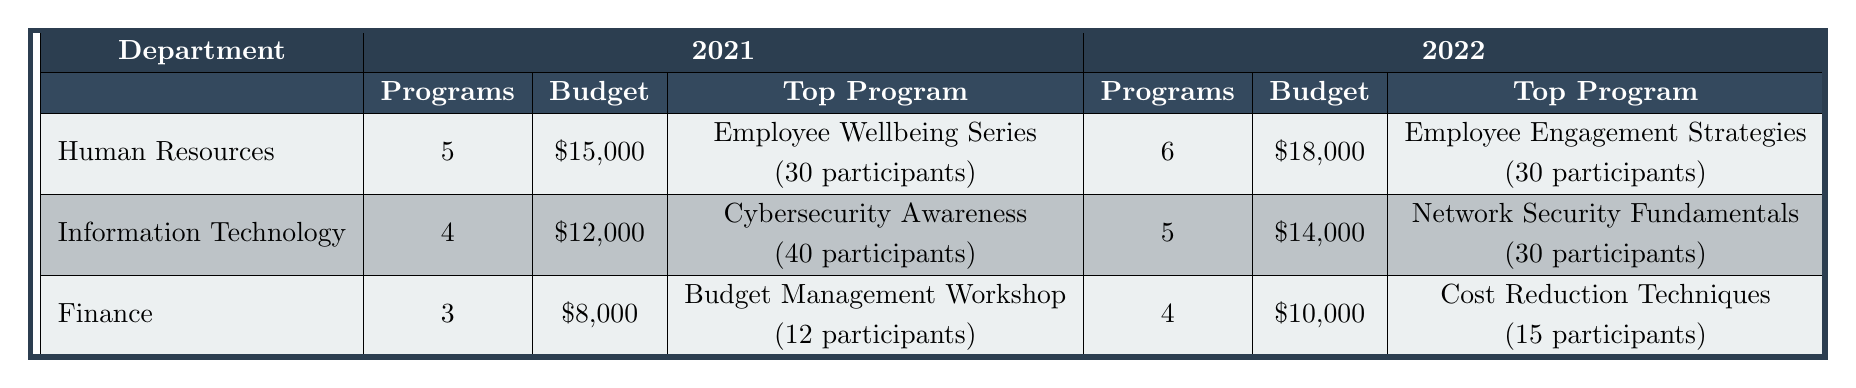What is the total budget allocated for Employee Training Programs in the year 2021? From the table, for 2021, the total budgets for each department are: Human Resources ($15,000), Information Technology ($12,000), and Finance ($8,000). Summing these values gives: $15,000 + $12,000 + $8,000 = $35,000.
Answer: $35,000 How many training programs were offered in the Information Technology department in 2022? According to the table, the Information Technology department offered 5 training programs in 2022 as indicated in the 'Programs' column.
Answer: 5 Which department had the highest number of participants in their top program for 2021? The top program in Human Resources had 30 participants (Employee Wellbeing Series), whereas Information Technology's top program had 40 participants (Cybersecurity Awareness). Therefore, Information Technology had the highest number with 40 participants.
Answer: Information Technology What is the difference in total budget between Human Resources and Finance for the year 2022? In the year 2022, Human Resources had a total budget of $18,000 and Finance had a total budget of $10,000. The difference is calculated as: $18,000 - $10,000 = $8,000.
Answer: $8,000 Did the total number of training programs in Human Resources increase from 2021 to 2022? In 2021, Human Resources offered 5 programs, and in 2022, they offered 6 programs. Since 6 is greater than 5, the total number of training programs did increase.
Answer: Yes What is the average number of participants across all training programs in the Finance department for 2021? The Finance department had 3 programs with the following participants: 12, 10, and 8. The average is calculated as: (12 + 10 + 8) / 3 = 10.
Answer: 10 Which department had the top program with the most participants in 2022? In 2022, Human Resources had a top program with 30 participants (Employee Engagement Strategies), but Information Technology had one with 30 participants (Network Security Fundamentals). However, both are tied here, so no department has more than 30.
Answer: Tie What is the total number of training programs conducted by the Finance department over the two years? For 2021, Finance conducted 3 programs, and in 2022, it conducted 4 programs. Adding these gives: 3 + 4 = 7.
Answer: 7 Which department saw the greatest increase in the number of training programs from 2021 to 2022? Human Resources increased from 5 to 6 programs (+1), Information Technology increased from 4 to 5 programs (+1), and Finance increased from 3 to 4 programs (+1). All departments saw the same increase of 1 program.
Answer: None (tie) 